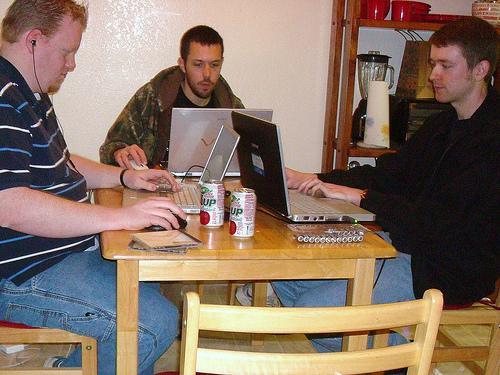In a formal report style, provide information about the furniture present in the image. The image displays a wooden dining table accompanied by multiple wooden chairs, positioned around the table. The table is occupied by various objects such as laptops and beverages. Can you identify the beverages present on the table and their quantity? Yes, there are two beverage cans on the table, likely a 7UP soda and an energy drink. Analyze the object interactions in the image, particularly the person and the computer mouse. A person is holding a black computer mouse, likely using it to navigate or perform actions on one of the laptops on the table. Evaluate the quality of the image based on its contents and provided information. The image quality is detailed and comprehensive, depicting various objects such as laptops, beverages, furniture, and individuals with their attributes and positions. What are the three young men using the laptops doing in the image? Three young men are sitting at a table, using their laptop computers, possibly for work, study, or leisure activities. Based on the image, how many laptops and beverage cans are present on the table? There are three laptops and two beverage cans on the table. In a casual conversational style, tell me how many laptops there are and what condition they're in. Hey there! Just so you know, there are three laptops in the picture, and all of them are open and being used. Determine the overall sentiment conveyed in the image. The sentiment conveyed in the image is focused, as the three young men appear to be engrossed in their work or activities on their laptops. Detect and describe any objects on the table that are powered by batteries. A bunch of batteries can be seen on the table; however, there are no visible objects powered by batteries. Is there any kitchen appliance in the image? If so, describe it. Yes, there is a mixer grinder placed on a rack, presumably on a shelf nearby the dining table. Describe the person who is holding the black mouse. A person wearing black shirt with short hair sitting at a table using a laptop, touching the mouse, and has ear buds in their ears. Recognize any text visible in the image. No visible text found. Have a look at the painting hanging just beside the wooden dining table. No, it's not mentioned in the image. Could you point out the vase of flowers placed near the wooden chair? There is no mention of a vase or flowers in the captions, which makes this instruction misleading. What type of chair is near the table? A wooden chair Segment and identify the different sections of the image. Table area, chair area, man holding mouse area, and mixer grinder area What color are the laptops on the table? They are black. What type of electronic devices are on the table? Laptops and batteries Find the object described as "a wood table and chairs". X:70 Y:145 Width:317 Height:317 Provide a caption for the scene where a person is holding a black color mouse. A person holding a black mouse while using a laptop at a table Identify the object located at X:197 and Y:156 with width 66 and height 66. Sodas on the table What is the sentiment conveyed by the image? Neutral or focused, as the people are working on their laptops and not showing strong emotions. Describe the object found at X:347 Y:30 with width 59 and height 59. A mixer grinder kept in the rack Identify any unusual objects or activities in the image. No unusual objects or activities detected. Count the number of laptops on the dining table. There are three laptops. Notice the umbrella stand placed by the door in the room. An umbrella stand is not listed among the objects in the image, so this direction would mislead people looking for one. Rate the image quality on a scale of 1 to 10. 8, as the objects are clearly visible but some items are partially overlapped or cropped. Identify any beverage containers in the image. 7 up tin, two beverage cans, and an energy drink can Describe the overall scene in the image. Three young men sitting at a table using laptops with various objects like drinks and batteries on the table. Spot the pizza box lying in the far corner of the room. None of the given objects or captions mention a pizza box, so this would confuse a viewer looking for one. List the objects that are in contact with the table. Laptops, 7 up tin, batteries, keyboard, beverage cans, package of batteries, cd cases Describe the interaction between the man and the black mouse. The man is touching and holding the black mouse while using his laptop. List all the objects that are kept on the dining table. Three laptops, 7 up tin, bunch of batteries, keyboard, wooden dining table, two beverage cans, package of batteries, cd cases Provide attributes of the wooden chair near the table. Brown, made out of wood, near the table 